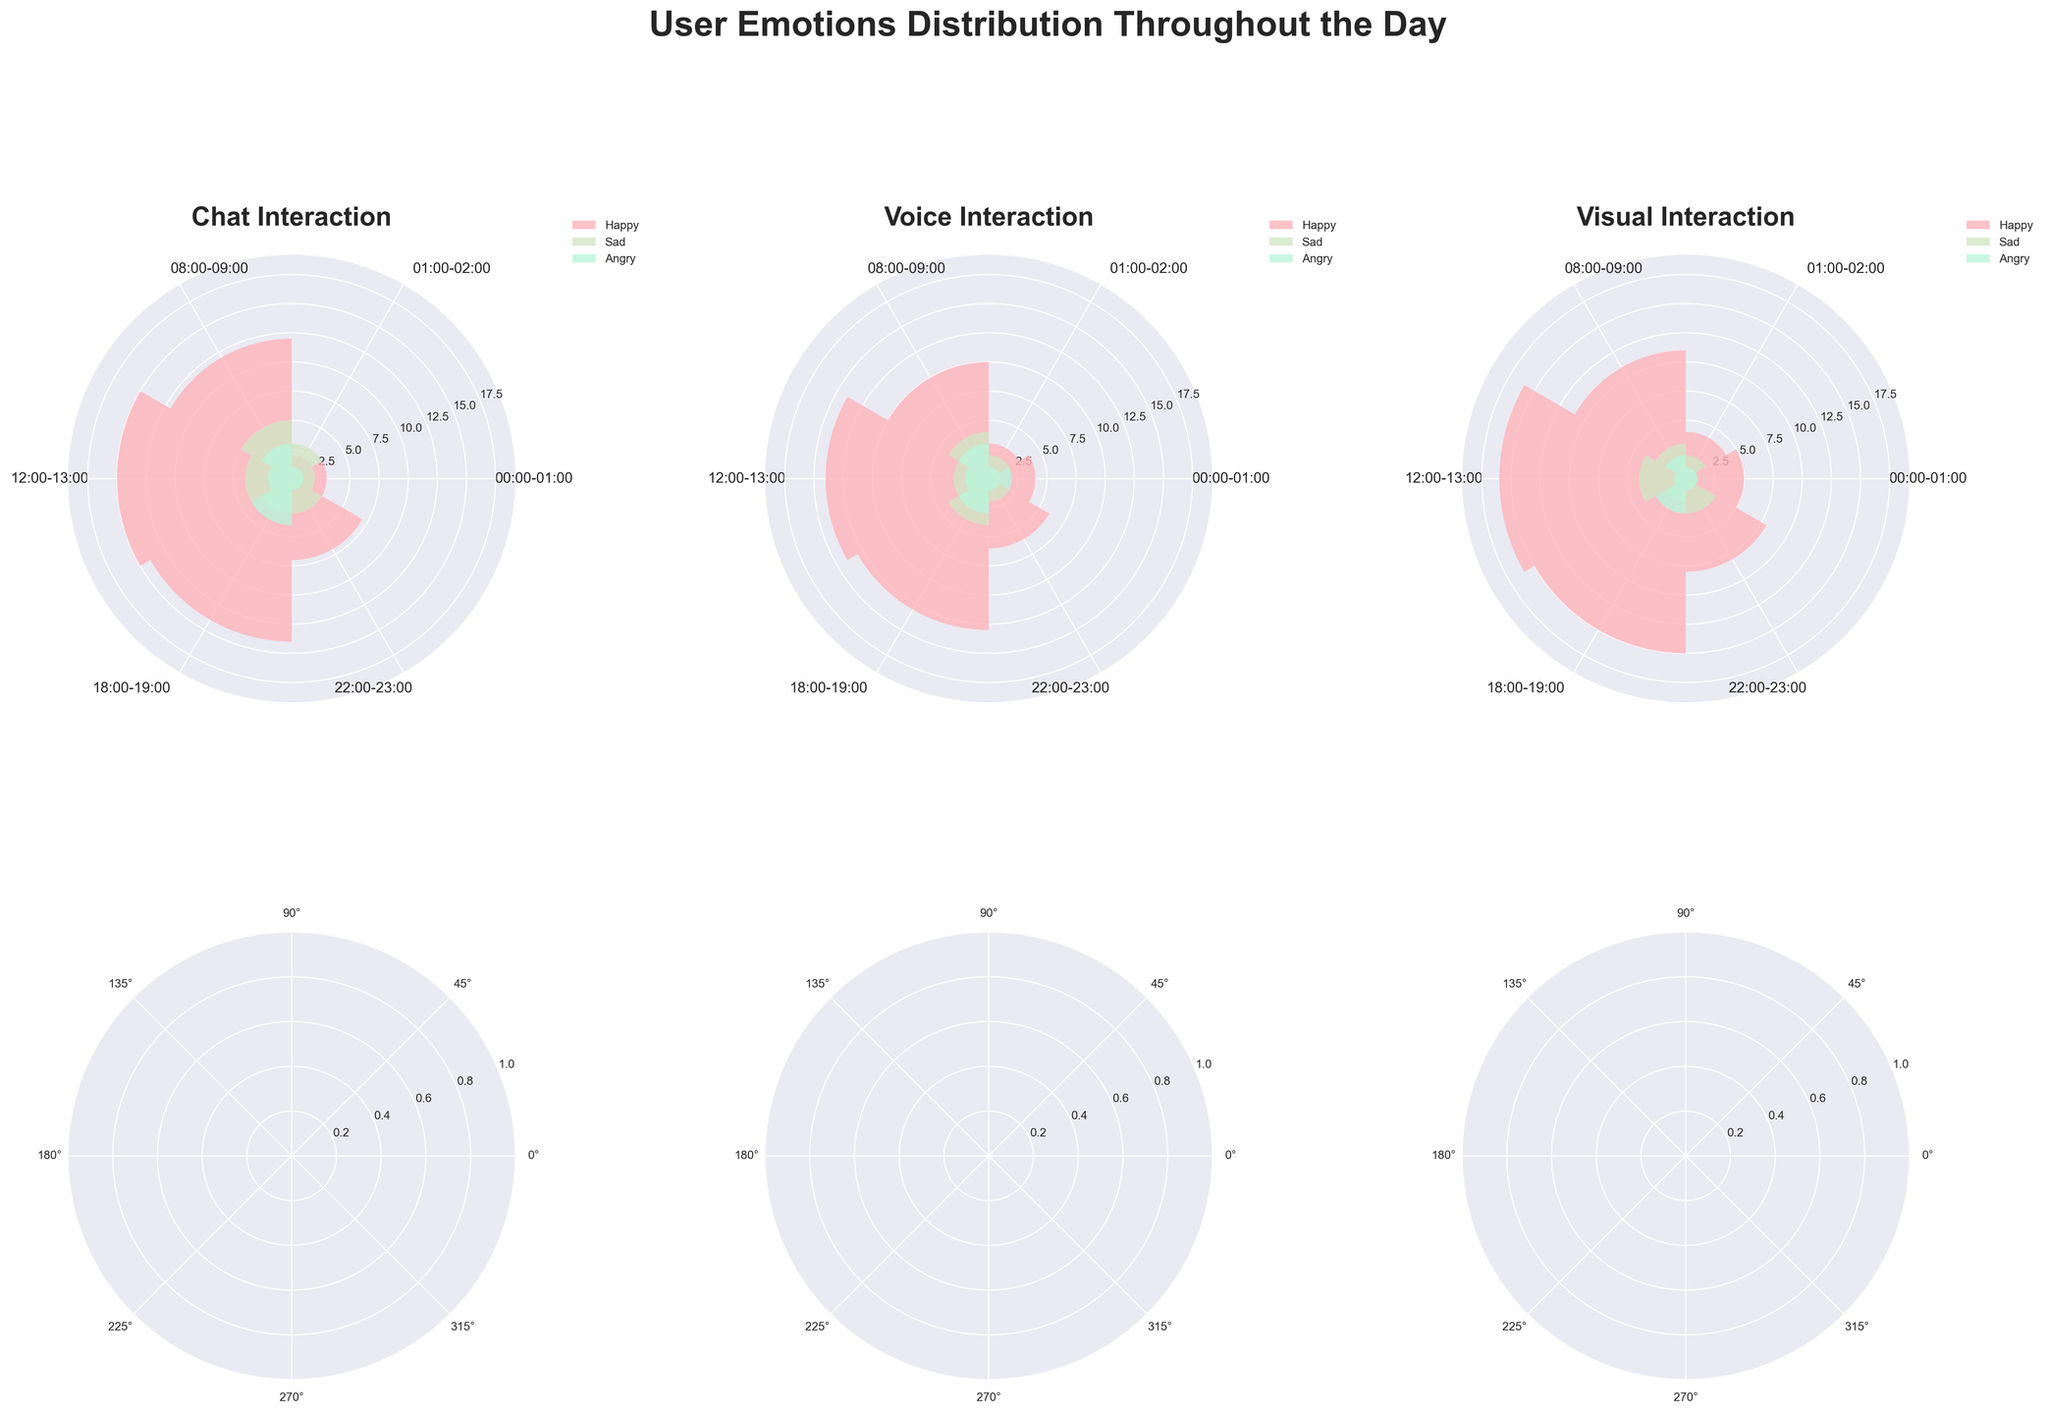What is the title of the figure? The title of the figure can be found at the top of the plot, usually in a larger and bold font to stand out. It is meant to give a brief idea about what the data represents.
Answer: User Emotions Distribution Throughout the Day Which emotional response had the highest count during the 12:00-13:00 time slot for Visual interactions? To find this, look at the segment of the rose chart corresponding to 12:00-13:00 for Visual interactions and identify the bar with the highest value.
Answer: Happy How does the count of Happy emotions compare between Visual and Chat interactions at 08:00-09:00? Compare the heights of the 'Happy' bars for both Visual and Chat interactions at the 08:00-09:00 time slot segment on their respective rose charts.
Answer: Visual has 11, Chat has 12; Chat is higher What is the total number of Angry interactions recorded between 00:00-01:00 and 01:00-02:00? Identify the Angry counts for each interaction type during 00:00-01:00 and 01:00-02:00, and sum them up. For 00:00-01:00: 1 (Chat) + 2 (Voice) + 1 (Visual) = 4. For 01:00-02:00: 1 (Chat) + 1 (Voice) + 1 (Visual) = 3. Summing these totals gives 4 + 3 = 7.
Answer: 7 During which time slot did Chat interactions have the lowest count of Happy emotions? Review each segment for Chat interactions and determine which one has the shortest 'Happy' bar.
Answer: 01:00-02:00 Is there any time slot where the count of Sad emotions is the same for all interaction types? Check each time slot and compare the heights of the 'Sad' bars across Chat, Voice, and Visual interactions to see if any time slot has equal counts.
Answer: 00:00-01:00 Which interaction type had the highest number of Happy emotions at 18:00-19:00? Identify the highest ‘Happy’ bar within the 18:00-19:00 segment for Chat, Voice, and Visual charts.
Answer: Visual What is the difference between the counts of Sad emotions in Chat interactions at 08:00-09:00 and at 12:00-13:00? Subtract the count of Sad emotions at 08:00-09:00 from the count at 12:00-13:00 for Chat interactions. The counts are 5 (08:00-09:00) and 4 (12:00-13:00), so 5 - 4 = 1.
Answer: 1 